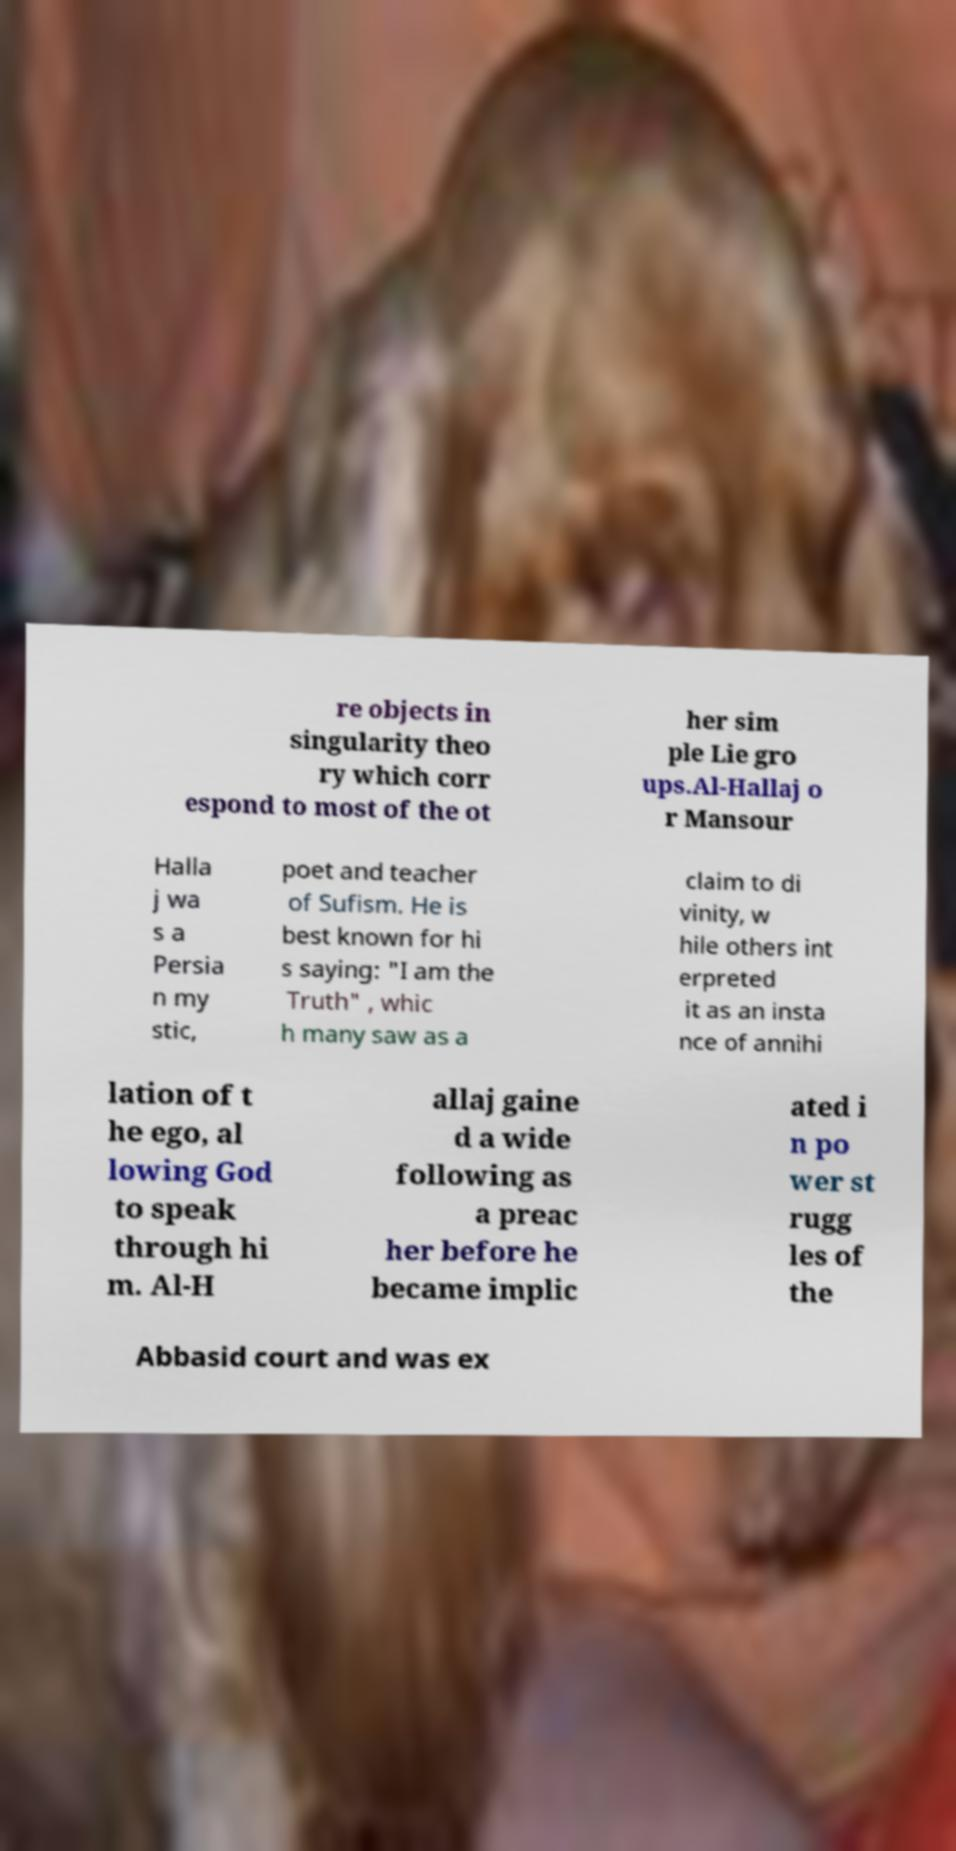Can you accurately transcribe the text from the provided image for me? re objects in singularity theo ry which corr espond to most of the ot her sim ple Lie gro ups.Al-Hallaj o r Mansour Halla j wa s a Persia n my stic, poet and teacher of Sufism. He is best known for hi s saying: "I am the Truth" , whic h many saw as a claim to di vinity, w hile others int erpreted it as an insta nce of annihi lation of t he ego, al lowing God to speak through hi m. Al-H allaj gaine d a wide following as a preac her before he became implic ated i n po wer st rugg les of the Abbasid court and was ex 